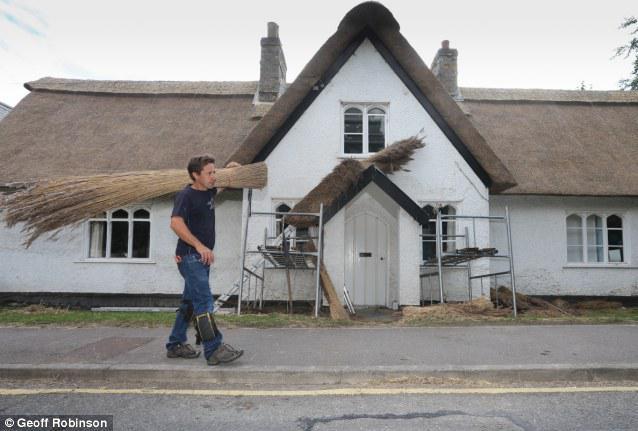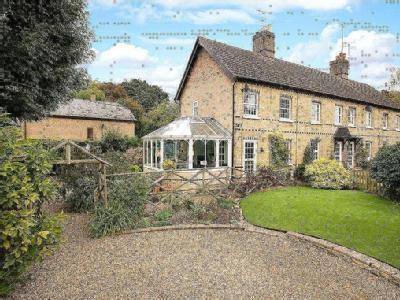The first image is the image on the left, the second image is the image on the right. Given the left and right images, does the statement "In the right image at least two chimneys are visible." hold true? Answer yes or no. Yes. 